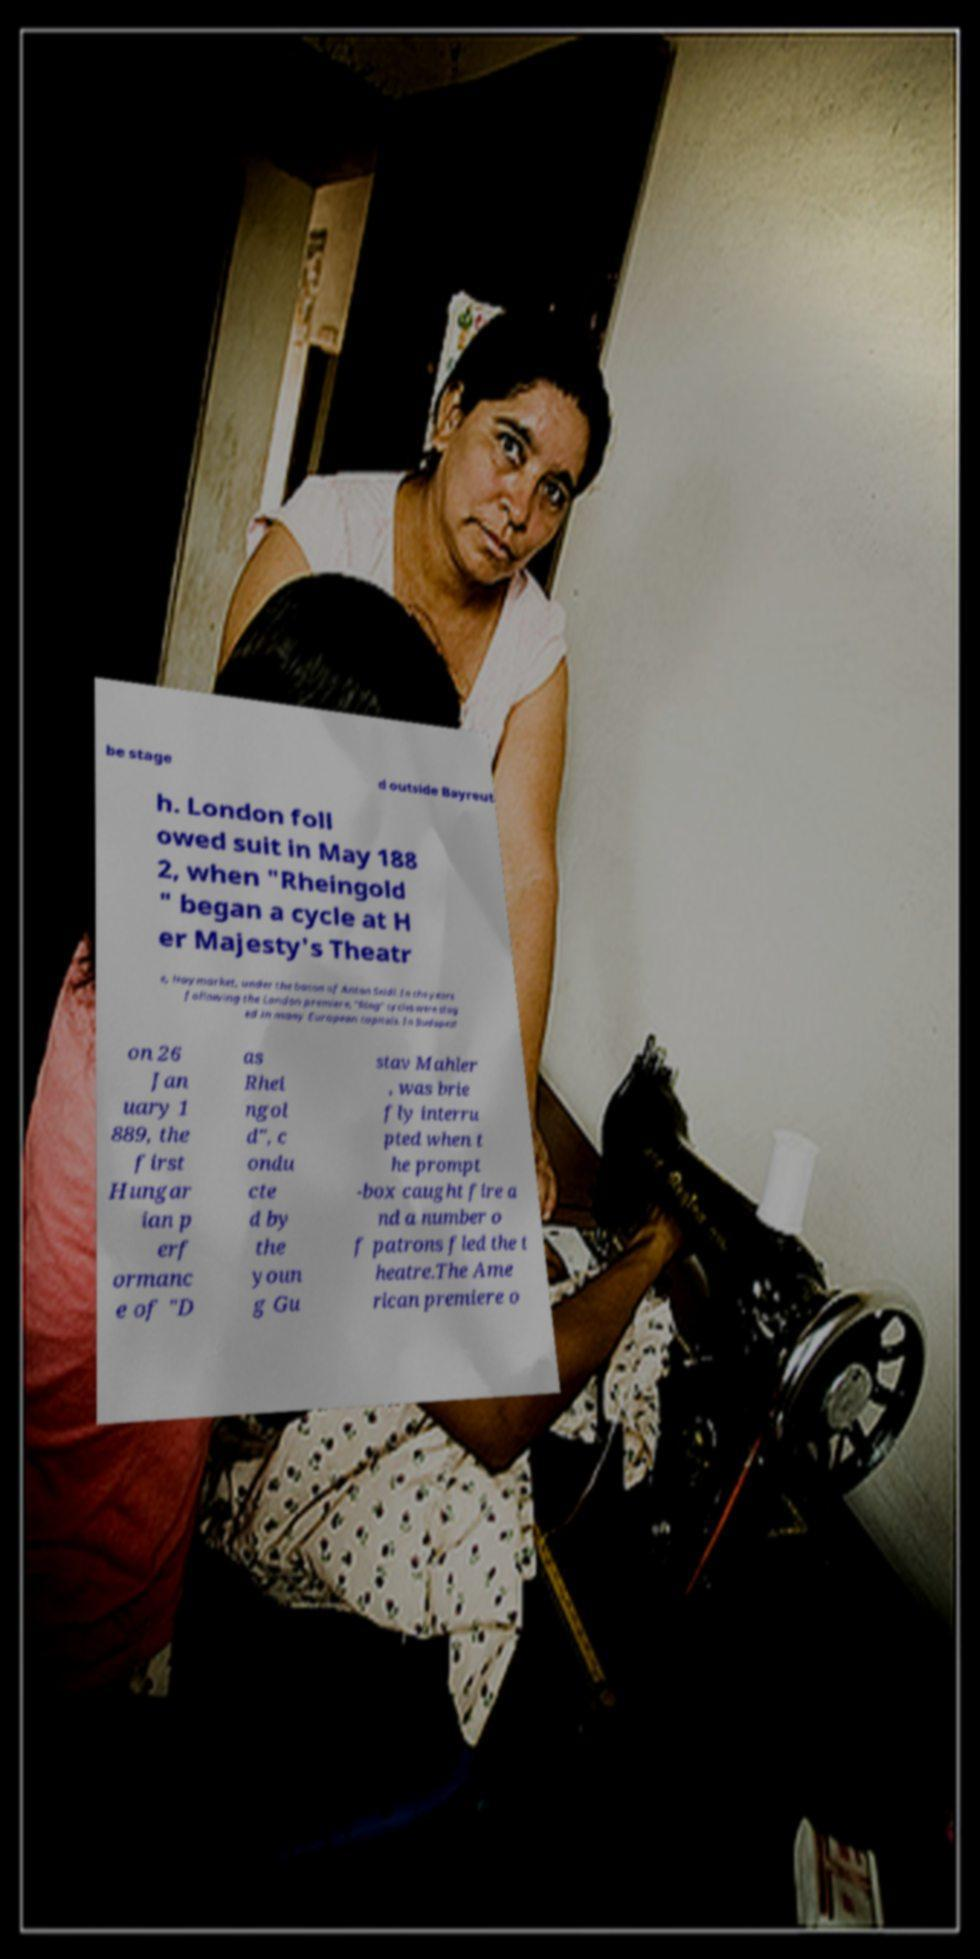I need the written content from this picture converted into text. Can you do that? be stage d outside Bayreut h. London foll owed suit in May 188 2, when "Rheingold " began a cycle at H er Majesty's Theatr e, Haymarket, under the baton of Anton Seidl. In the years following the London premiere, "Ring" cycles were stag ed in many European capitals. In Budapest on 26 Jan uary 1 889, the first Hungar ian p erf ormanc e of "D as Rhei ngol d", c ondu cte d by the youn g Gu stav Mahler , was brie fly interru pted when t he prompt -box caught fire a nd a number o f patrons fled the t heatre.The Ame rican premiere o 